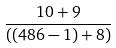Convert formula to latex. <formula><loc_0><loc_0><loc_500><loc_500>\frac { 1 0 + 9 } { ( ( 4 8 6 - 1 ) + 8 ) }</formula> 